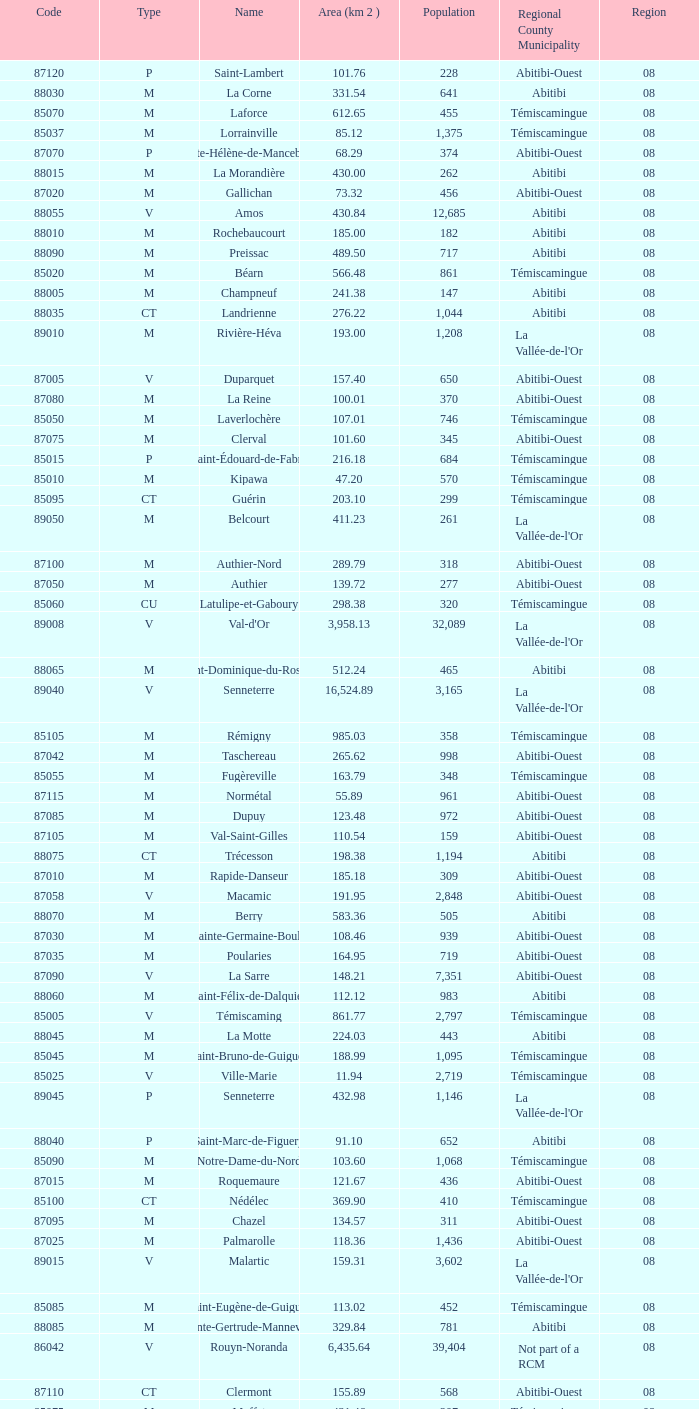What municipality has 719 people and is larger than 108.46 km2? Abitibi-Ouest. 